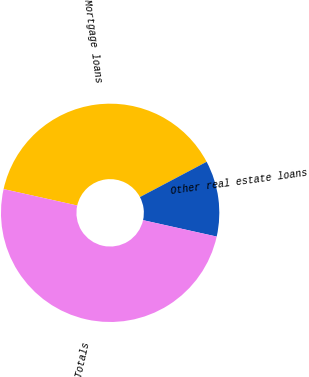<chart> <loc_0><loc_0><loc_500><loc_500><pie_chart><fcel>Mortgage loans<fcel>Other real estate loans<fcel>Totals<nl><fcel>38.77%<fcel>11.23%<fcel>50.0%<nl></chart> 